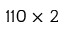<formula> <loc_0><loc_0><loc_500><loc_500>1 1 0 \times 2</formula> 